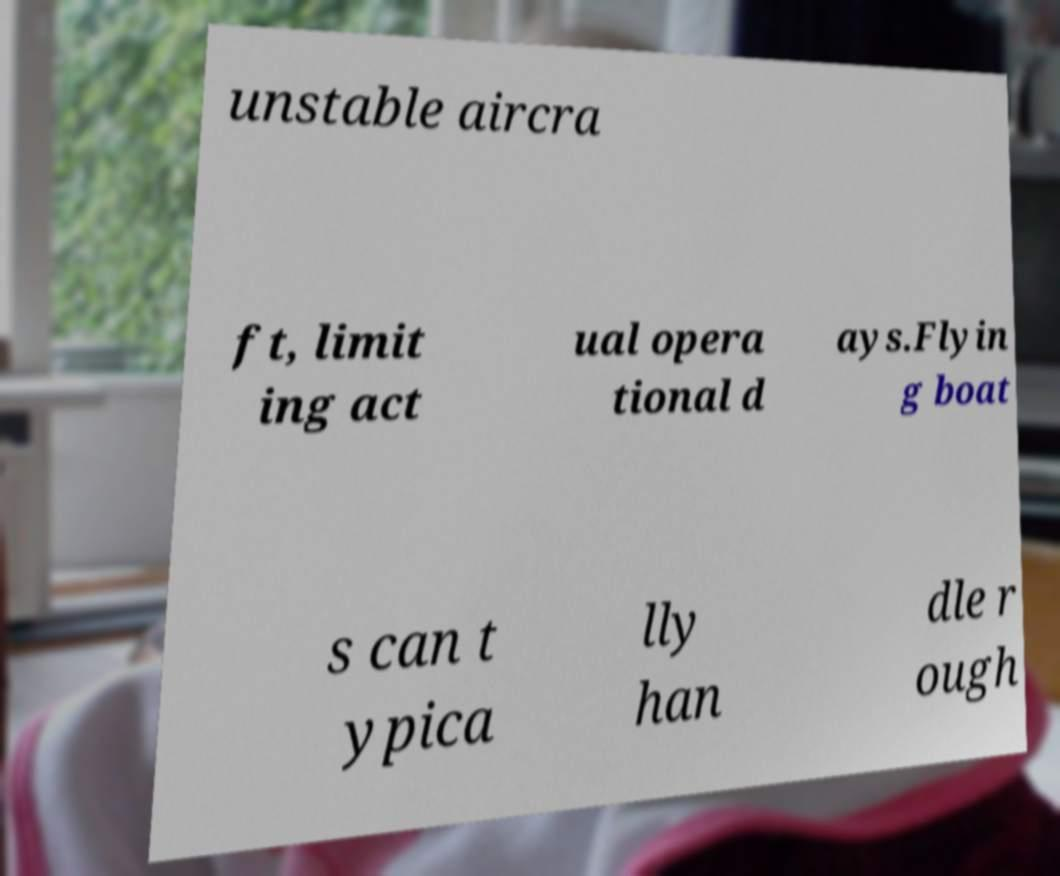Could you extract and type out the text from this image? unstable aircra ft, limit ing act ual opera tional d ays.Flyin g boat s can t ypica lly han dle r ough 